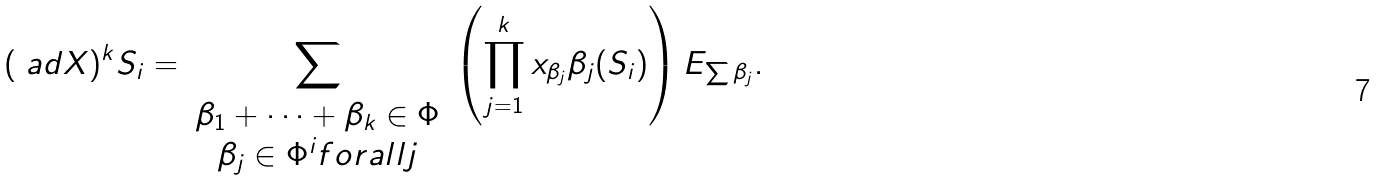Convert formula to latex. <formula><loc_0><loc_0><loc_500><loc_500>( \ a d X ) ^ { k } S _ { i } = \sum _ { \begin{array} { c } \beta _ { 1 } + \cdots + \beta _ { k } \in \Phi \\ \beta _ { j } \in \Phi ^ { i } f o r a l l j \end{array} } \left ( \prod _ { j = 1 } ^ { k } x _ { \beta _ { j } } \beta _ { j } ( S _ { i } ) \right ) E _ { \sum \beta _ { j } } .</formula> 